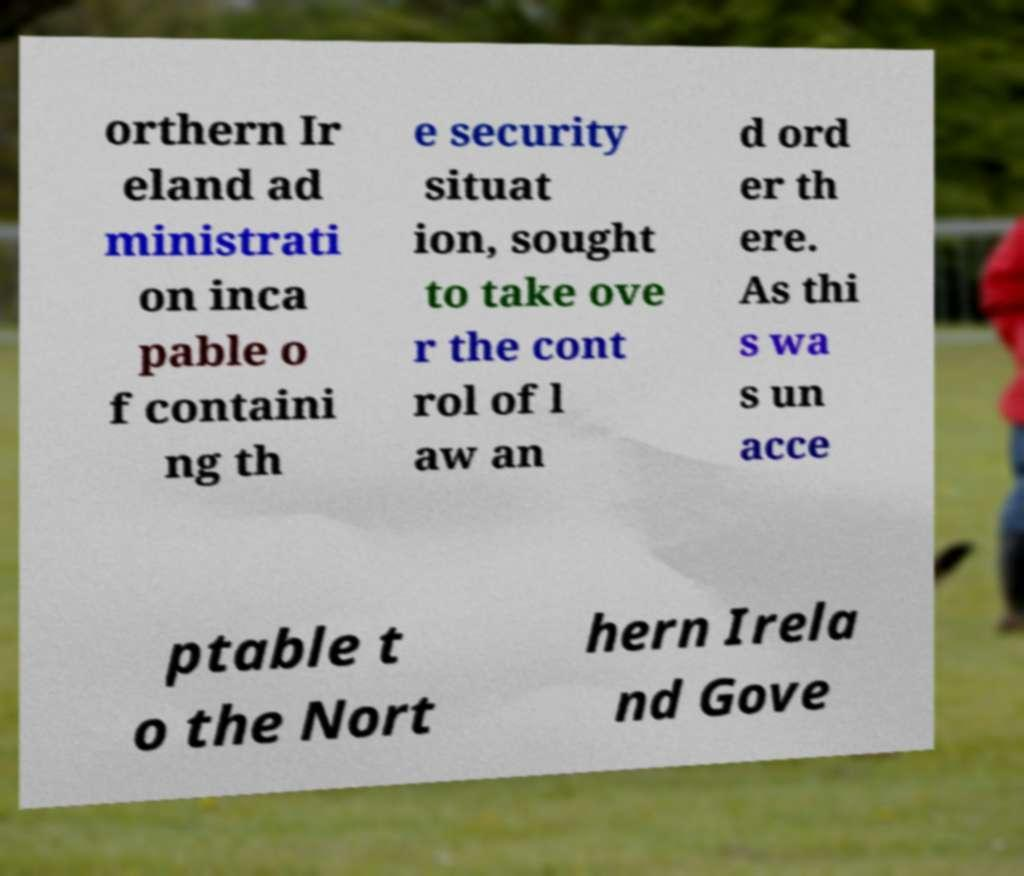For documentation purposes, I need the text within this image transcribed. Could you provide that? orthern Ir eland ad ministrati on inca pable o f containi ng th e security situat ion, sought to take ove r the cont rol of l aw an d ord er th ere. As thi s wa s un acce ptable t o the Nort hern Irela nd Gove 